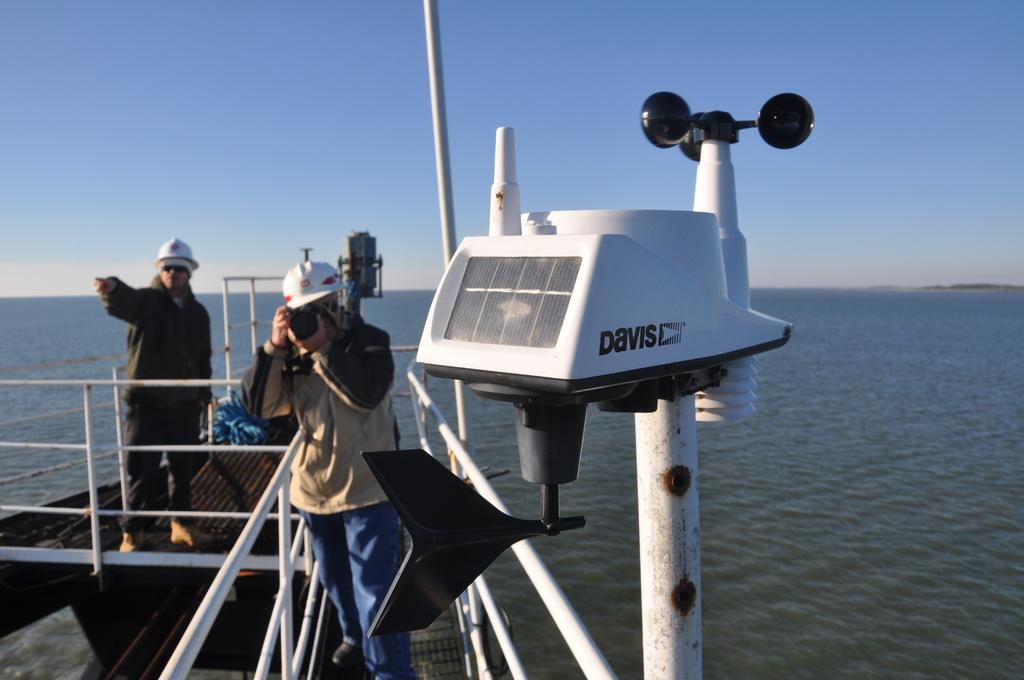Provide a one-sentence caption for the provided image. a man is on a boat, taking a photo, and there is a Davis mechanism on the boat. 